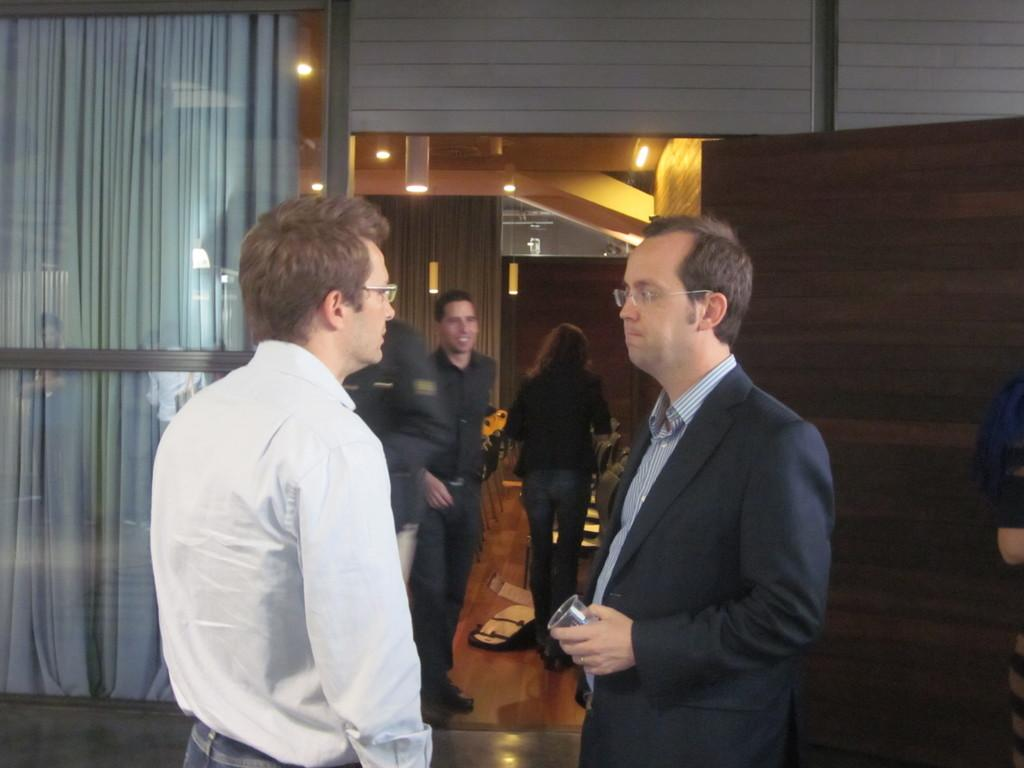What are the people in the image doing? The persons in the image are on the floor. What object can be seen for holding liquids? There is a glass in the image. What type of window treatment is present in the image? There are curtains in the image. What can be used for illumination in the image? There are lights in the image. What architectural feature is present in the image that can be used for entering or exiting a room? There is a door in the image. What type of structure is present in the image that separates spaces? There is a wall in the image. How does the scale of the board affect the size of the persons in the image? There is no board present in the image, so it cannot affect the size of the persons. What can be done to increase the number of lights in the image? The number of lights in the image cannot be increased, as it is a static image. 